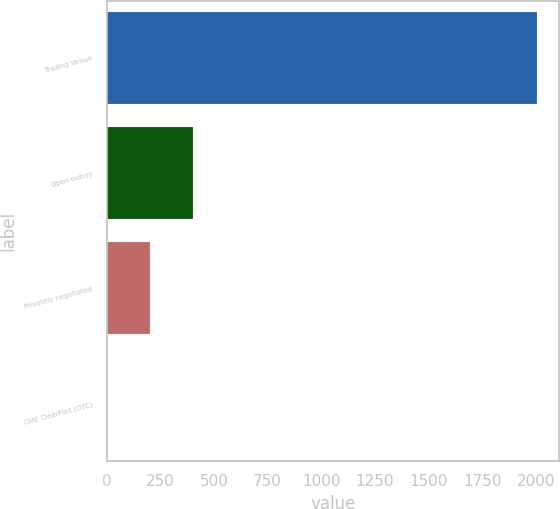Convert chart. <chart><loc_0><loc_0><loc_500><loc_500><bar_chart><fcel>Trading Venue<fcel>Open outcry<fcel>Privately negotiated<fcel>CME ClearPort (OTC)<nl><fcel>2008<fcel>404.8<fcel>204.4<fcel>4<nl></chart> 